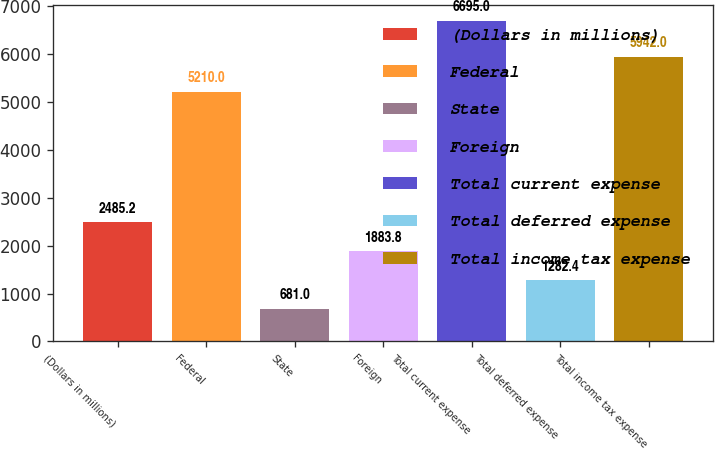<chart> <loc_0><loc_0><loc_500><loc_500><bar_chart><fcel>(Dollars in millions)<fcel>Federal<fcel>State<fcel>Foreign<fcel>Total current expense<fcel>Total deferred expense<fcel>Total income tax expense<nl><fcel>2485.2<fcel>5210<fcel>681<fcel>1883.8<fcel>6695<fcel>1282.4<fcel>5942<nl></chart> 